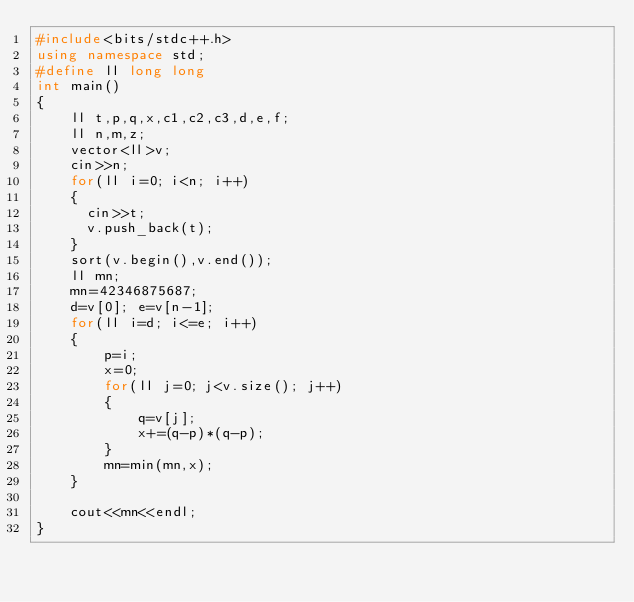<code> <loc_0><loc_0><loc_500><loc_500><_C++_>#include<bits/stdc++.h>
using namespace std;
#define ll long long
int main()
{
    ll t,p,q,x,c1,c2,c3,d,e,f;
    ll n,m,z;
    vector<ll>v;
    cin>>n;
    for(ll i=0; i<n; i++)
    {
      cin>>t;
      v.push_back(t);
    }
    sort(v.begin(),v.end());
    ll mn;
    mn=42346875687;
    d=v[0]; e=v[n-1];
    for(ll i=d; i<=e; i++)
    {
        p=i;
        x=0;
        for(ll j=0; j<v.size(); j++)
        {
            q=v[j];
            x+=(q-p)*(q-p);
        }
        mn=min(mn,x);
    }

    cout<<mn<<endl;
}






</code> 